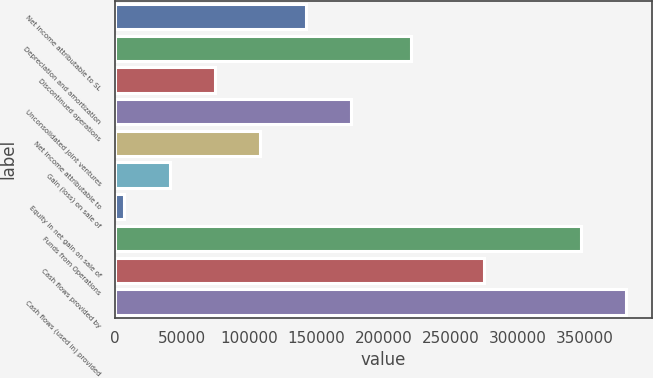<chart> <loc_0><loc_0><loc_500><loc_500><bar_chart><fcel>Net income attributable to SL<fcel>Depreciation and amortization<fcel>Discontinued operations<fcel>Unconsolidated joint ventures<fcel>Net income attributable to<fcel>Gain (loss) on sale of<fcel>Equity in net gain on sale of<fcel>Funds from Operations<fcel>Cash flows provided by<fcel>Cash flows (used in) provided<nl><fcel>142166<fcel>220396<fcel>74428.6<fcel>176035<fcel>108297<fcel>40559.8<fcel>6691<fcel>346875<fcel>275211<fcel>380744<nl></chart> 